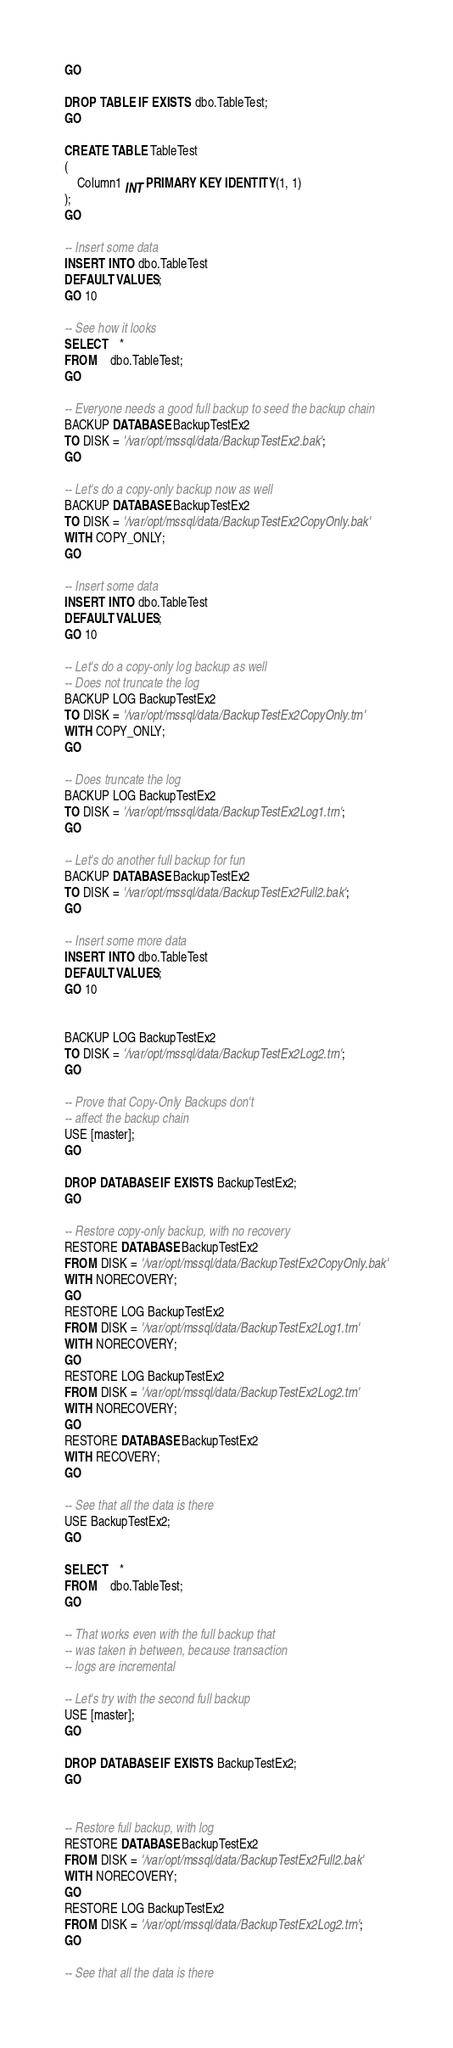Convert code to text. <code><loc_0><loc_0><loc_500><loc_500><_SQL_>GO

DROP TABLE IF EXISTS dbo.TableTest;
GO

CREATE TABLE TableTest
(
	Column1 INT PRIMARY KEY IDENTITY(1, 1)
);
GO

-- Insert some data
INSERT INTO dbo.TableTest
DEFAULT VALUES;
GO 10

-- See how it looks
SELECT	*
FROM	dbo.TableTest;
GO

-- Everyone needs a good full backup to seed the backup chain
BACKUP DATABASE BackupTestEx2
TO DISK = '/var/opt/mssql/data/BackupTestEx2.bak';
GO

-- Let's do a copy-only backup now as well
BACKUP DATABASE BackupTestEx2
TO DISK = '/var/opt/mssql/data/BackupTestEx2CopyOnly.bak'
WITH COPY_ONLY;
GO

-- Insert some data
INSERT INTO dbo.TableTest
DEFAULT VALUES;
GO 10

-- Let's do a copy-only log backup as well
-- Does not truncate the log
BACKUP LOG BackupTestEx2
TO DISK = '/var/opt/mssql/data/BackupTestEx2CopyOnly.trn'
WITH COPY_ONLY;
GO

-- Does truncate the log
BACKUP LOG BackupTestEx2
TO DISK = '/var/opt/mssql/data/BackupTestEx2Log1.trn';
GO

-- Let's do another full backup for fun
BACKUP DATABASE BackupTestEx2
TO DISK = '/var/opt/mssql/data/BackupTestEx2Full2.bak';
GO

-- Insert some more data
INSERT INTO dbo.TableTest
DEFAULT VALUES;
GO 10


BACKUP LOG BackupTestEx2
TO DISK = '/var/opt/mssql/data/BackupTestEx2Log2.trn';
GO

-- Prove that Copy-Only Backups don't
-- affect the backup chain
USE [master];
GO

DROP DATABASE IF EXISTS BackupTestEx2;
GO

-- Restore copy-only backup, with no recovery 
RESTORE DATABASE BackupTestEx2
FROM DISK = '/var/opt/mssql/data/BackupTestEx2CopyOnly.bak'
WITH NORECOVERY;
GO
RESTORE LOG BackupTestEx2
FROM DISK = '/var/opt/mssql/data/BackupTestEx2Log1.trn'
WITH NORECOVERY;
GO
RESTORE LOG BackupTestEx2
FROM DISK = '/var/opt/mssql/data/BackupTestEx2Log2.trn'
WITH NORECOVERY;
GO
RESTORE DATABASE BackupTestEx2
WITH RECOVERY;
GO

-- See that all the data is there
USE BackupTestEx2;
GO

SELECT	*
FROM	dbo.TableTest;
GO

-- That works even with the full backup that
-- was taken in between, because transaction
-- logs are incremental

-- Let's try with the second full backup
USE [master];
GO

DROP DATABASE IF EXISTS BackupTestEx2;
GO


-- Restore full backup, with log
RESTORE DATABASE BackupTestEx2
FROM DISK = '/var/opt/mssql/data/BackupTestEx2Full2.bak'
WITH NORECOVERY;
GO
RESTORE LOG BackupTestEx2
FROM DISK = '/var/opt/mssql/data/BackupTestEx2Log2.trn';
GO

-- See that all the data is there</code> 